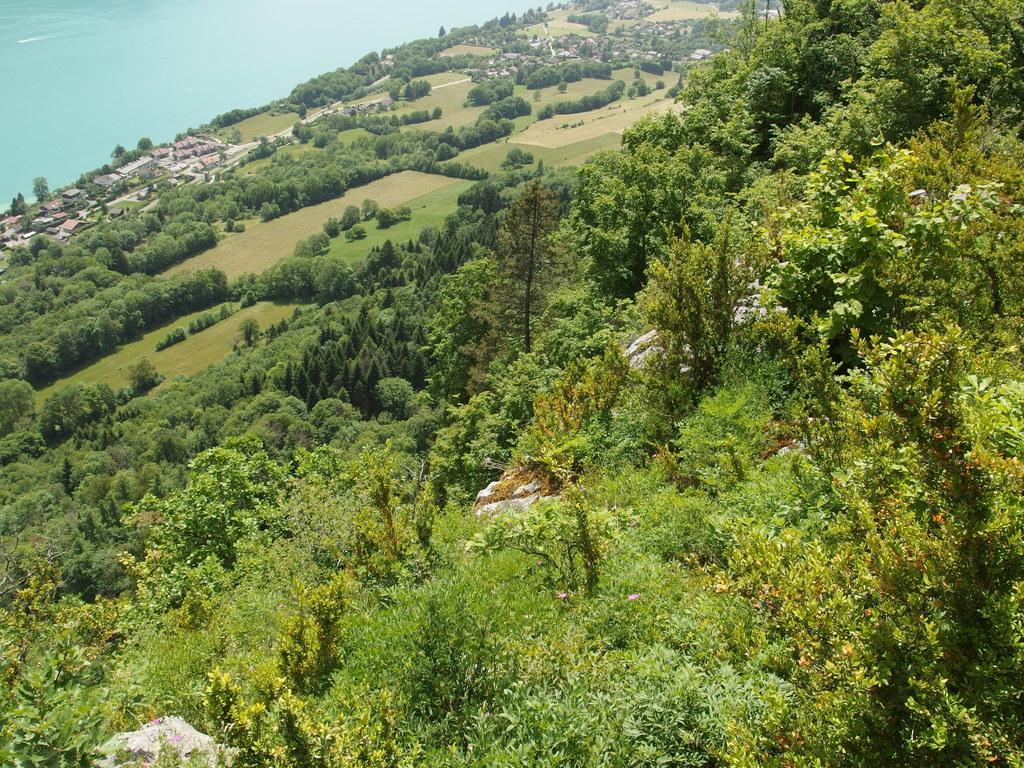How would you summarize this image in a sentence or two? In this picture I can see trees and few houses and I can see water. 